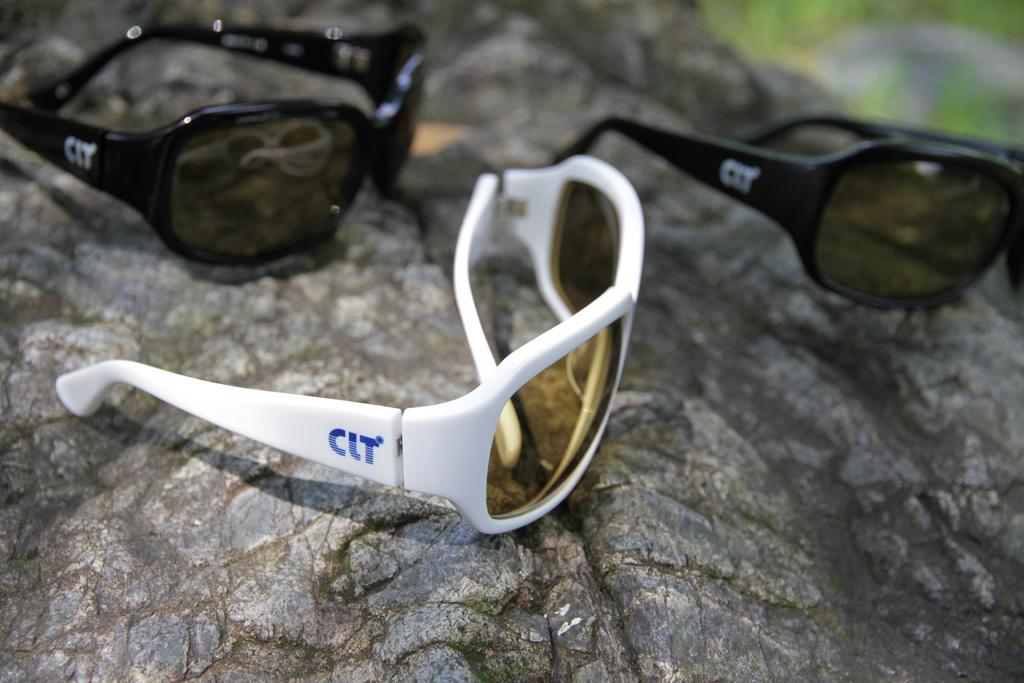In one or two sentences, can you explain what this image depicts? In this image I can see glasses on the rock among them two are black and one is white in color. 